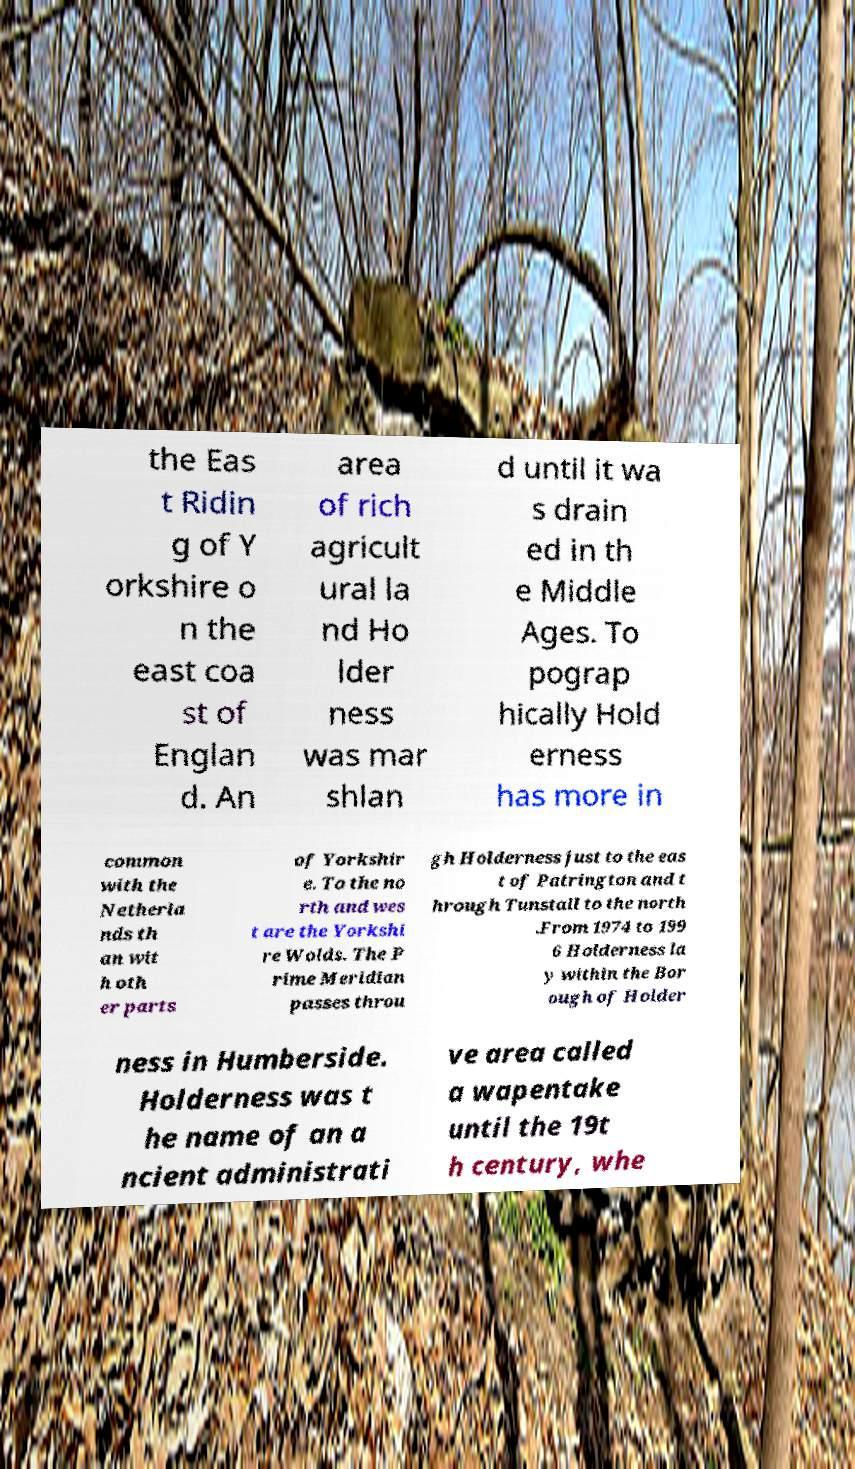There's text embedded in this image that I need extracted. Can you transcribe it verbatim? the Eas t Ridin g of Y orkshire o n the east coa st of Englan d. An area of rich agricult ural la nd Ho lder ness was mar shlan d until it wa s drain ed in th e Middle Ages. To pograp hically Hold erness has more in common with the Netherla nds th an wit h oth er parts of Yorkshir e. To the no rth and wes t are the Yorkshi re Wolds. The P rime Meridian passes throu gh Holderness just to the eas t of Patrington and t hrough Tunstall to the north .From 1974 to 199 6 Holderness la y within the Bor ough of Holder ness in Humberside. Holderness was t he name of an a ncient administrati ve area called a wapentake until the 19t h century, whe 